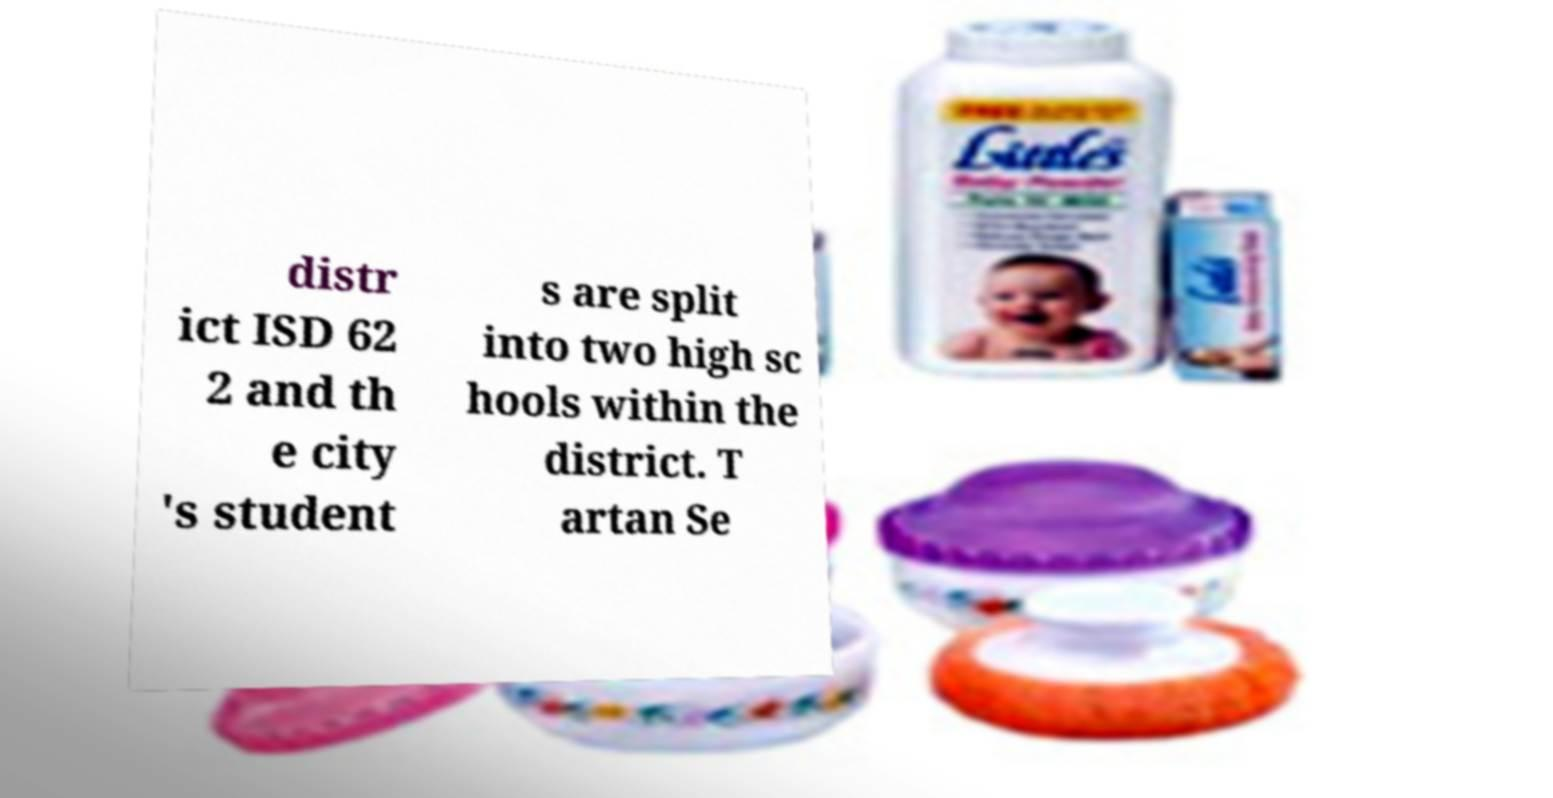Please identify and transcribe the text found in this image. distr ict ISD 62 2 and th e city 's student s are split into two high sc hools within the district. T artan Se 